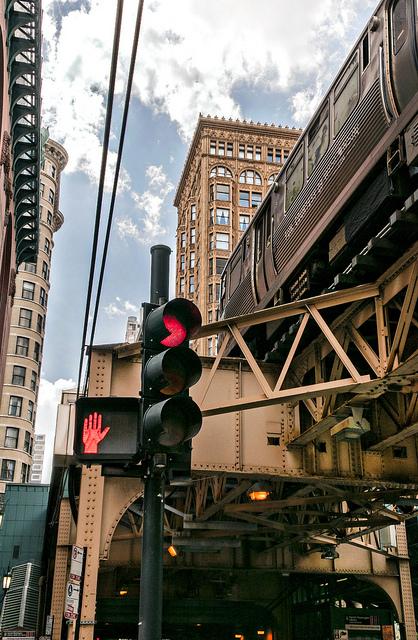What does the red hand on the light mean?
Write a very short answer. Stop. What color is the light?
Answer briefly. Red. What do the hand sign and the red light in the picture have in common?
Concise answer only. Stop. 